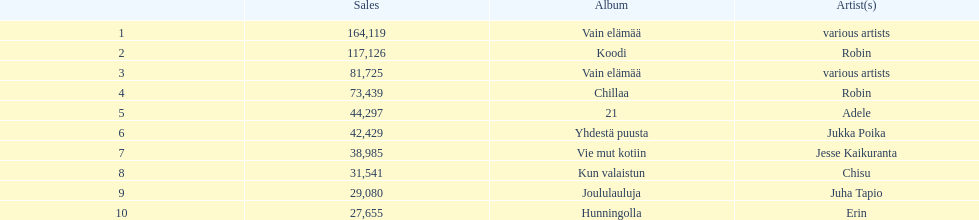Which album has the highest number of sales but doesn't have a designated artist? Vain elämää. 